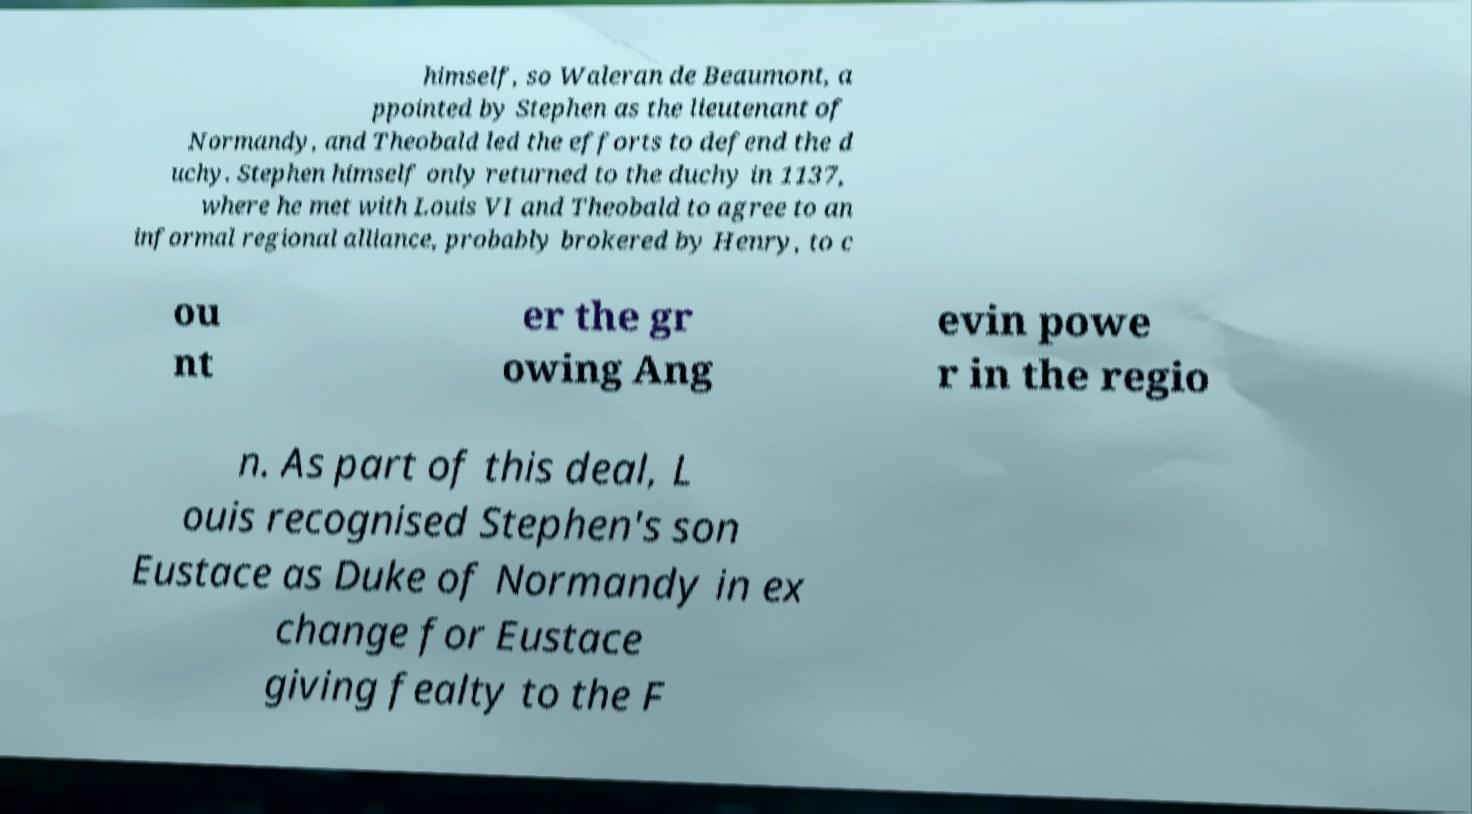Please identify and transcribe the text found in this image. himself, so Waleran de Beaumont, a ppointed by Stephen as the lieutenant of Normandy, and Theobald led the efforts to defend the d uchy. Stephen himself only returned to the duchy in 1137, where he met with Louis VI and Theobald to agree to an informal regional alliance, probably brokered by Henry, to c ou nt er the gr owing Ang evin powe r in the regio n. As part of this deal, L ouis recognised Stephen's son Eustace as Duke of Normandy in ex change for Eustace giving fealty to the F 